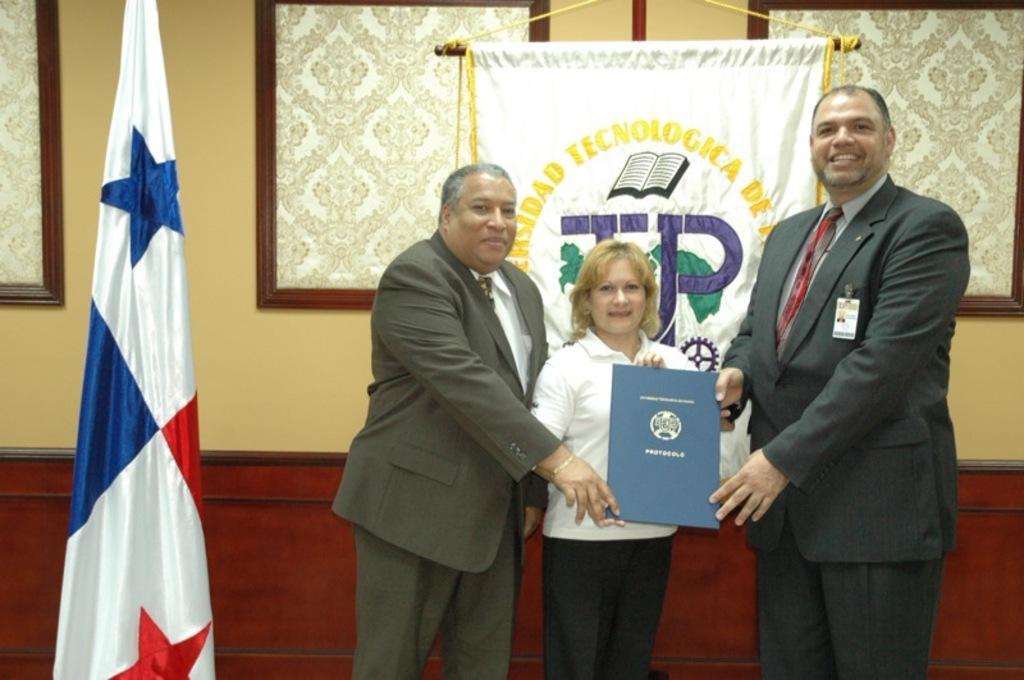Can you describe this image briefly? In this picture I can see there are three persons standing and the person at right is wearing a blazer and is smiling, he is holding a certificate. The person at left is wearing a blazer and is smiling. He is also holding the certificate and there is a woman at the center and she is wearing a white shirt and she is smiling. There is a flag on to left and there is a banner in the backdrop and there is a wall. 